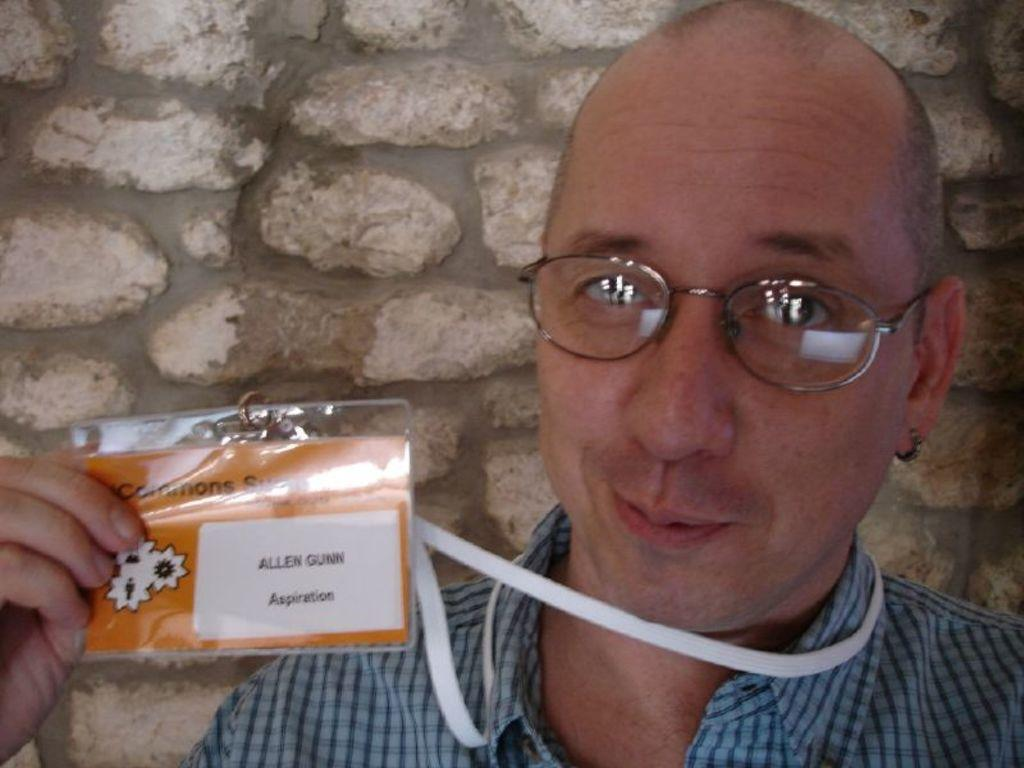What can be seen in the image? There is a person in the image. Can you describe the person's appearance? The person is wearing spectacles and is smiling. What is the person holding in their hand? The person is holding an ID card in their hand. What can be seen in the background of the image? There is a stone wall in the background of the image. What type of alarm is going off in the image? There is no alarm present in the image. Is the person wearing a cap in the image? The provided facts do not mention a cap, so it cannot be determined if the person is wearing one. 